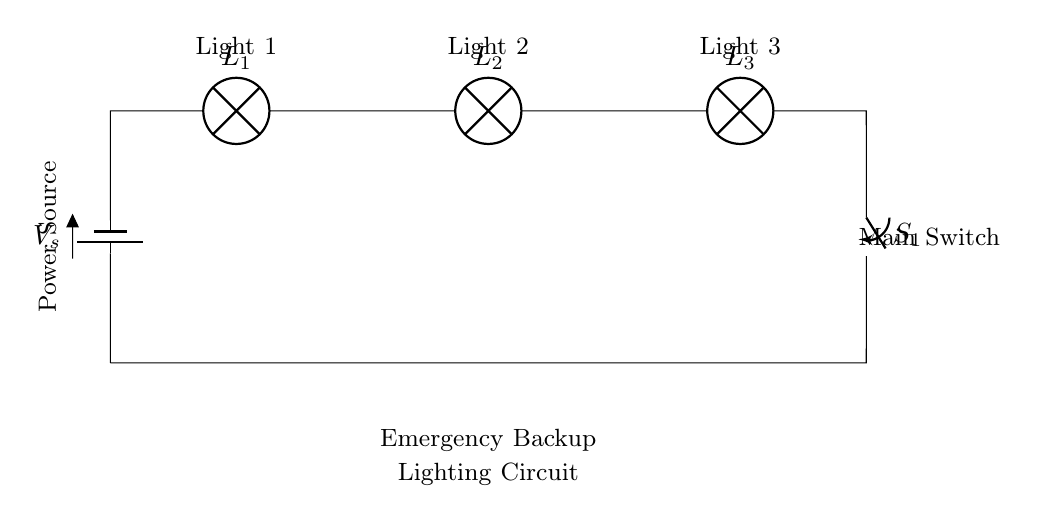What is the type of circuit depicted? The circuit is a series circuit, as indicated by the configuration where all components are connected end-to-end, forming a single path for current flow.
Answer: Series circuit How many lamps are in the circuit? The circuit diagram clearly shows three lamps connected in series, each identifiable by their respective labels.
Answer: Three lamps What is the purpose of the switch in this circuit? The main switch can control the flow of electricity in the circuit. When the switch is open, it prevents current from flowing, turning all lamps off. When closed, current flows through all components.
Answer: Control current What happens to the total resistance if one lamp fails? In a series circuit, if one lamp (component) fails or is removed, it creates an open circuit. This means current cannot flow, and all lamps will go out as a result.
Answer: All lamps go out If one lamp has a resistance of ten ohms, what is the total resistance? In a series circuit, the total resistance is the sum of the individual resistances. Here, if each lamp has ten ohms, the total resistance would be ten ohms multiplied by three lamps, giving a total of thirty ohms.
Answer: Thirty ohms How does this circuit assist during power outages? This emergency backup lighting circuit is designed to provide illumination when the main power supply fails. The battery serves as a backup source to power the lamps, ensuring safety and visibility.
Answer: Provides illumination 